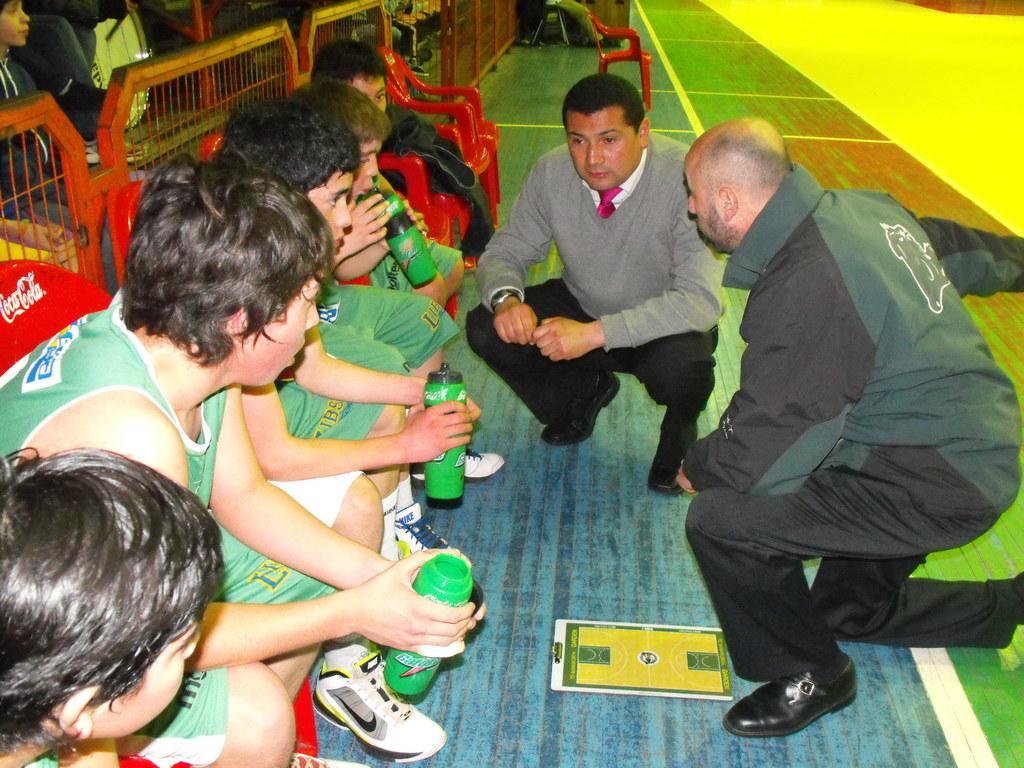Could you give a brief overview of what you see in this image? There are some boys. They are listening keenly to a man in squat position. They are looking like a team player. They are sitting on red colored chairs. There is barricade behind them. There are few audience behind the barricade. 